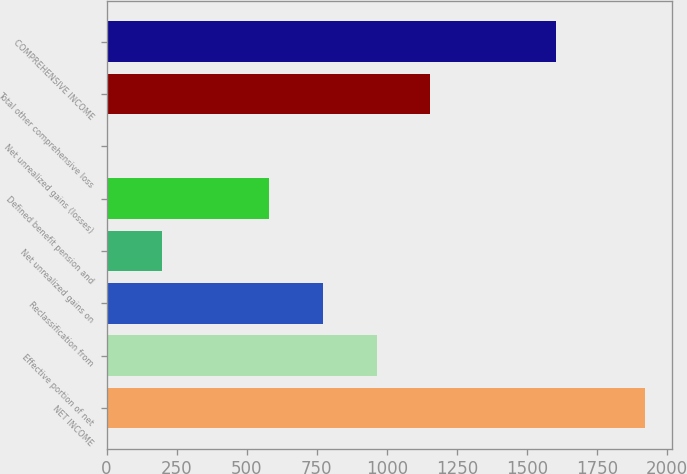Convert chart to OTSL. <chart><loc_0><loc_0><loc_500><loc_500><bar_chart><fcel>NET INCOME<fcel>Effective portion of net<fcel>Reclassification from<fcel>Net unrealized gains on<fcel>Defined benefit pension and<fcel>Net unrealized gains (losses)<fcel>Total other comprehensive loss<fcel>COMPREHENSIVE INCOME<nl><fcel>1923<fcel>964<fcel>772.2<fcel>196.8<fcel>580.4<fcel>5<fcel>1155.8<fcel>1603<nl></chart> 